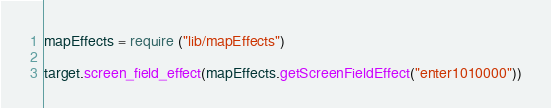<code> <loc_0><loc_0><loc_500><loc_500><_Lua_>mapEffects = require ("lib/mapEffects")

target.screen_field_effect(mapEffects.getScreenFieldEffect("enter1010000"))</code> 